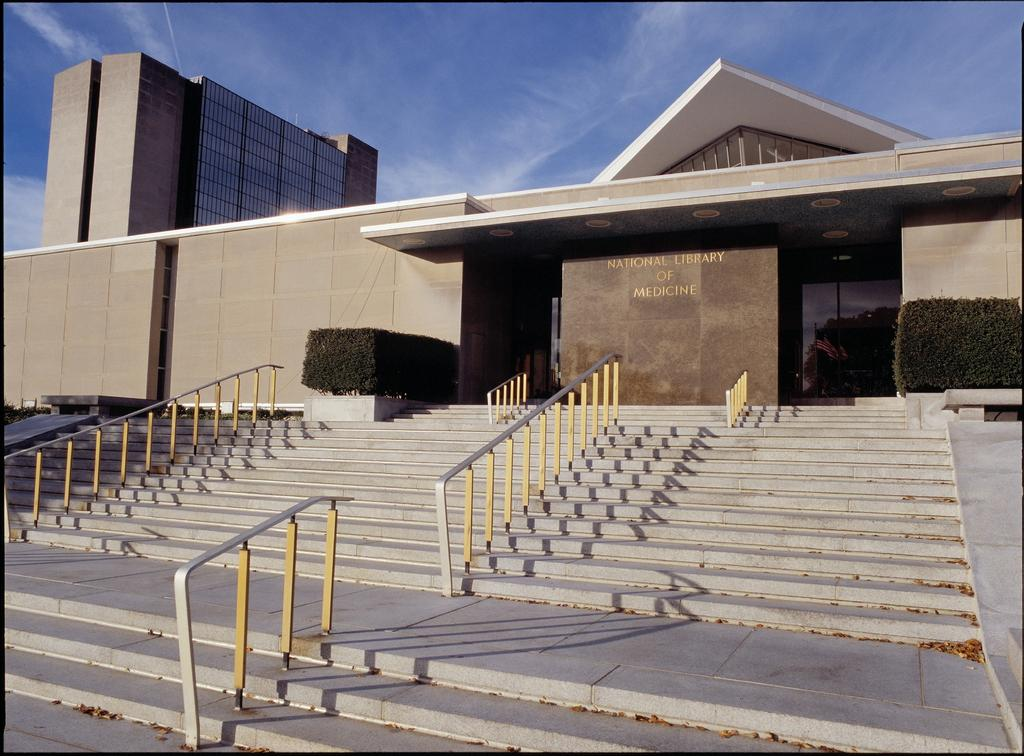What type of objects are made of metal and visible in the image? There are metal rods in the image. What type of structures can be seen in the image? There are buildings in the image. What type of vegetation is present in the image? There are shrubs in the image. What time of day is it in the image, and how does the sun's ray appear? The time of day cannot be determined from the image, and there is no mention of the sun's ray. How can someone help the metal rods in the image? The metal rods do not require help, as they are inanimate objects. 